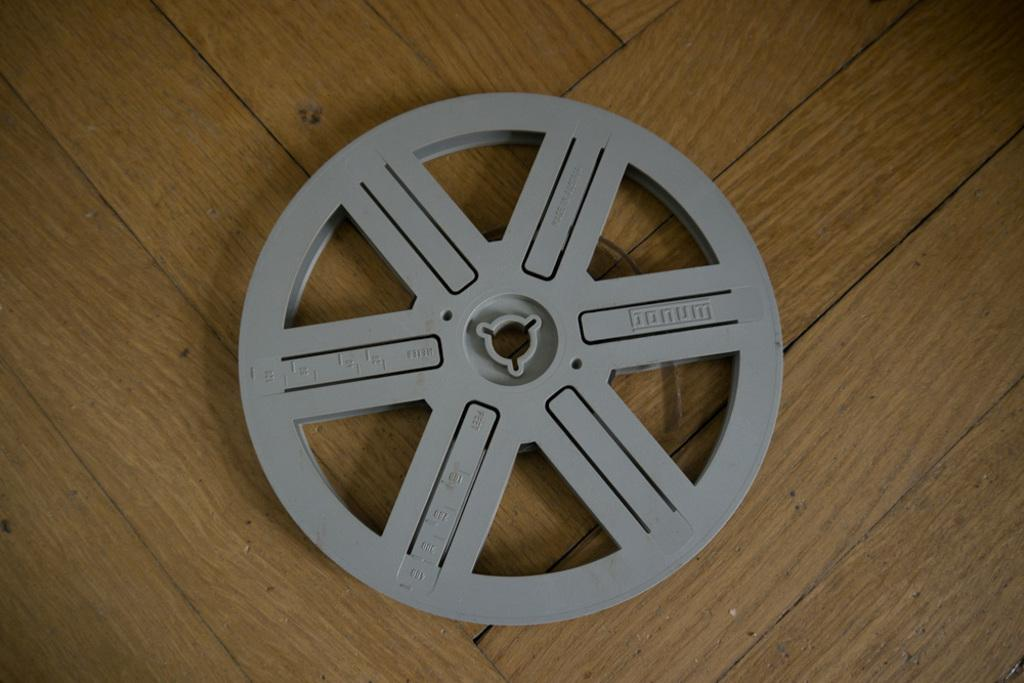What is the main object in the image? There is a wheel in the image. Where is the wheel located? The wheel is placed on a table. What word is being used to describe the wheel in the image? There is no specific word being used to describe the wheel in the image; it is simply referred to as a wheel. 